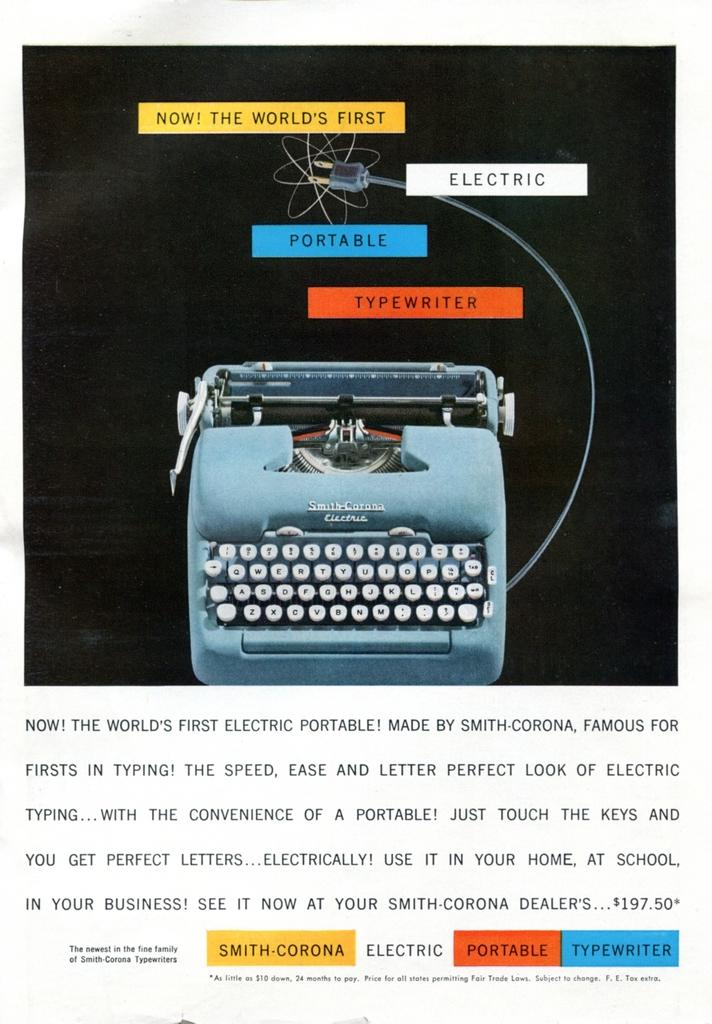<image>
Summarize the visual content of the image. the world's first portable electric typewriter with a paragraph describing it 